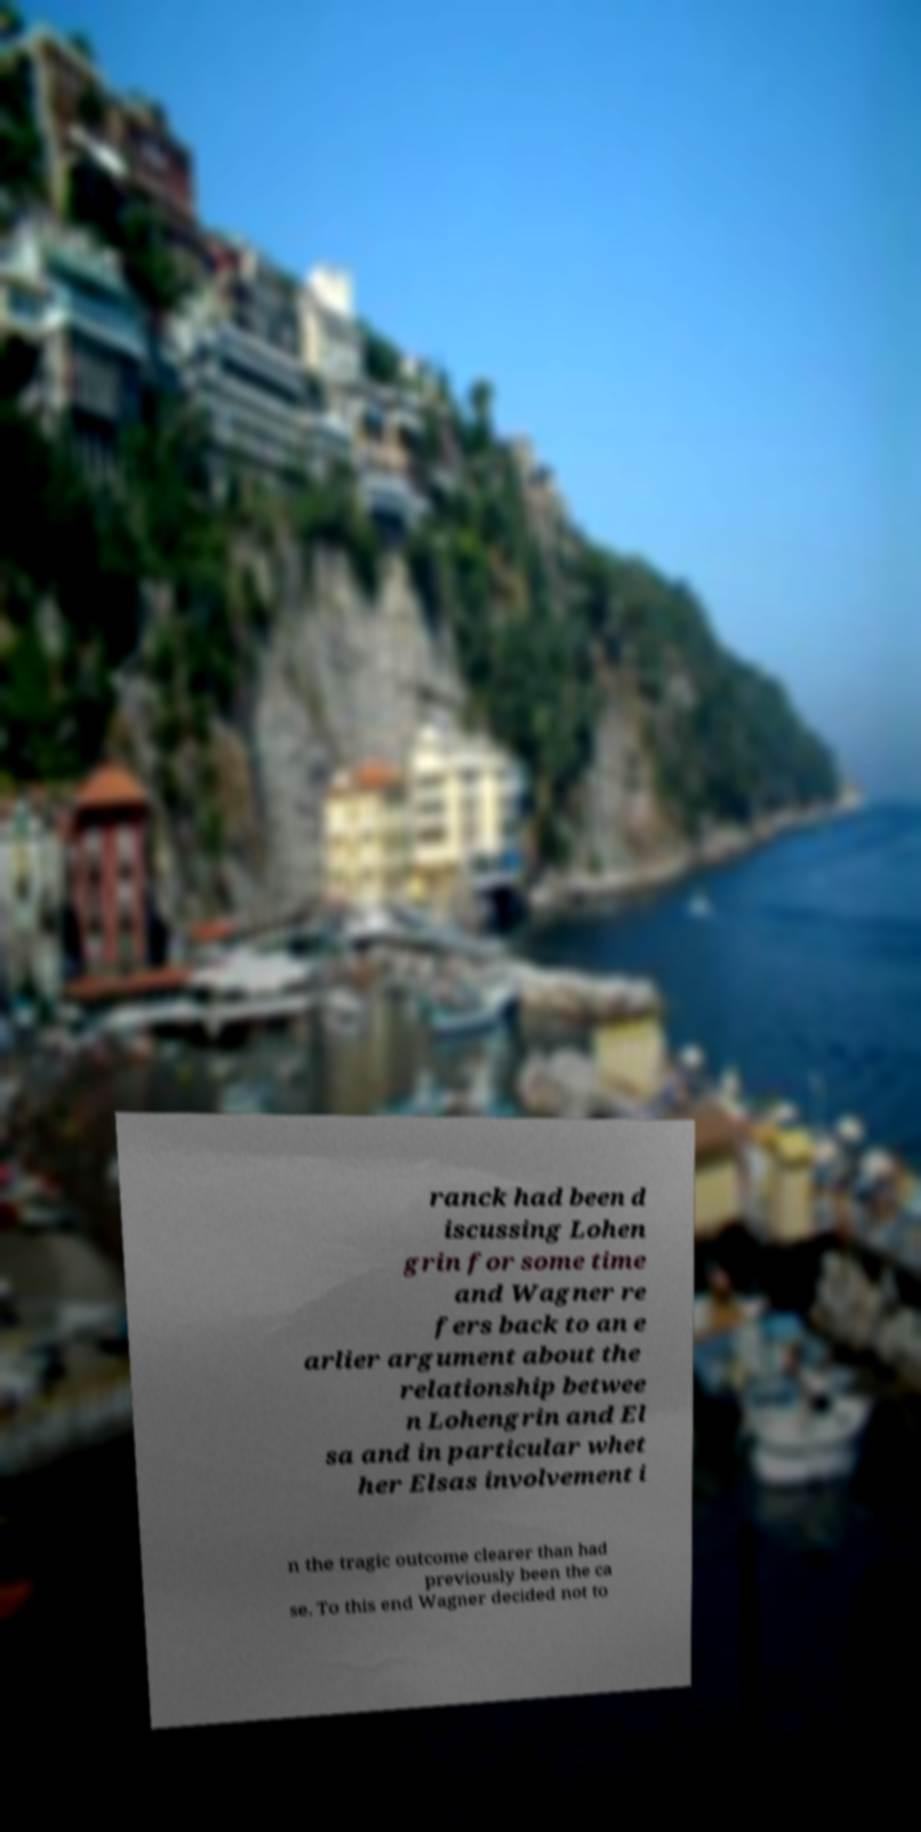Please identify and transcribe the text found in this image. ranck had been d iscussing Lohen grin for some time and Wagner re fers back to an e arlier argument about the relationship betwee n Lohengrin and El sa and in particular whet her Elsas involvement i n the tragic outcome clearer than had previously been the ca se. To this end Wagner decided not to 